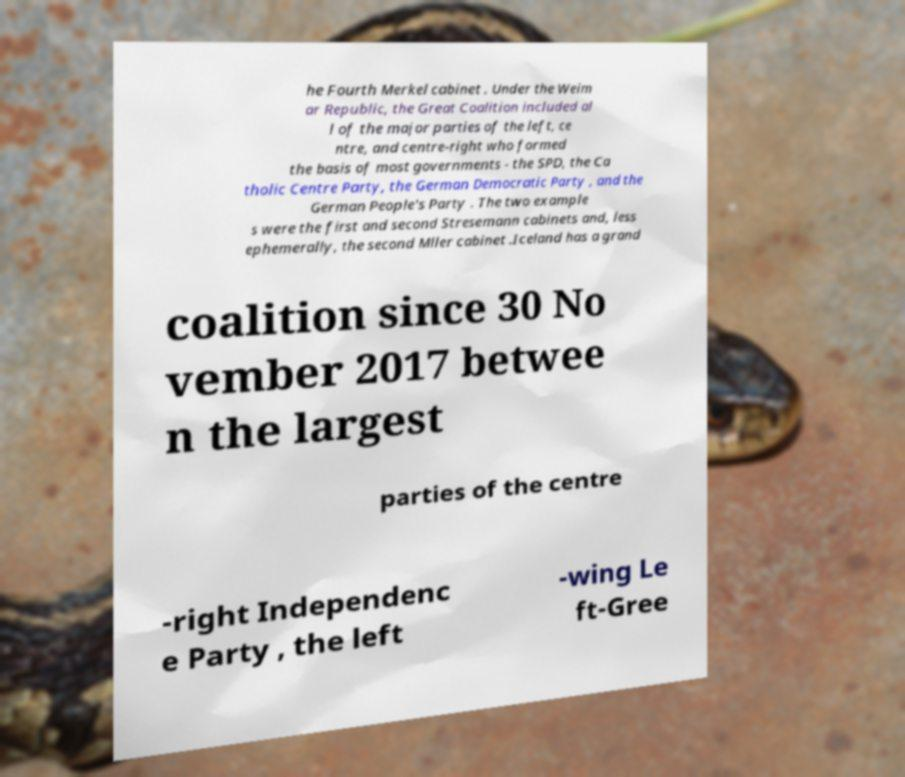There's text embedded in this image that I need extracted. Can you transcribe it verbatim? he Fourth Merkel cabinet . Under the Weim ar Republic, the Great Coalition included al l of the major parties of the left, ce ntre, and centre-right who formed the basis of most governments - the SPD, the Ca tholic Centre Party, the German Democratic Party , and the German People's Party . The two example s were the first and second Stresemann cabinets and, less ephemerally, the second Mller cabinet .Iceland has a grand coalition since 30 No vember 2017 betwee n the largest parties of the centre -right Independenc e Party , the left -wing Le ft-Gree 